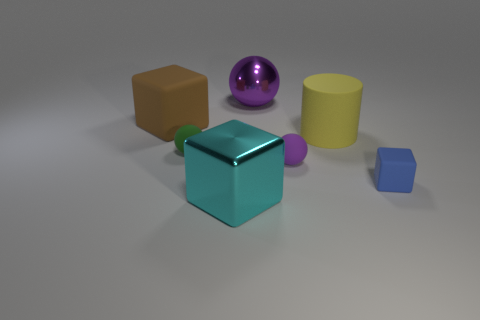What number of metal balls are there?
Your response must be concise. 1. There is a large rubber object that is on the left side of the big purple metal ball; is its shape the same as the big purple metal thing?
Your answer should be compact. No. There is a purple ball that is the same size as the blue rubber thing; what is its material?
Keep it short and to the point. Rubber. Is there a yellow cylinder that has the same material as the big purple thing?
Offer a very short reply. No. There is a small purple object; is its shape the same as the large metal thing behind the large brown matte thing?
Give a very brief answer. Yes. What number of blocks are on the left side of the purple rubber object and in front of the large cylinder?
Ensure brevity in your answer.  1. Do the green object and the purple thing that is in front of the green ball have the same material?
Keep it short and to the point. Yes. Are there an equal number of tiny purple balls right of the small blue block and gray shiny cylinders?
Ensure brevity in your answer.  Yes. There is a metal thing that is in front of the blue block; what is its color?
Your answer should be compact. Cyan. What number of other objects are the same color as the small cube?
Provide a short and direct response. 0. 